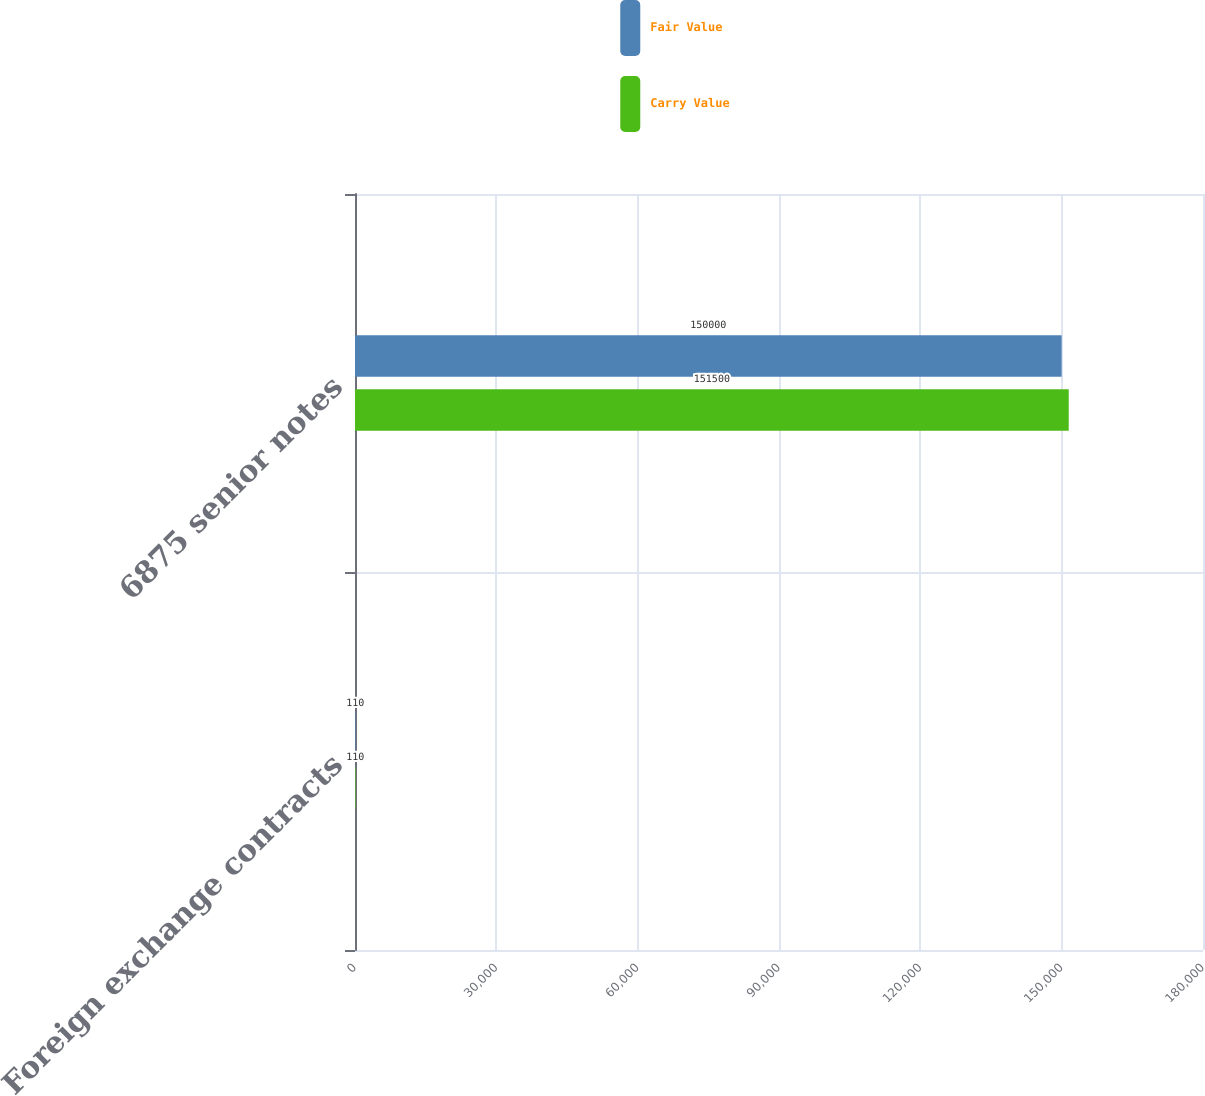Convert chart to OTSL. <chart><loc_0><loc_0><loc_500><loc_500><stacked_bar_chart><ecel><fcel>Foreign exchange contracts<fcel>6875 senior notes<nl><fcel>Fair Value<fcel>110<fcel>150000<nl><fcel>Carry Value<fcel>110<fcel>151500<nl></chart> 